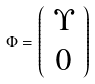<formula> <loc_0><loc_0><loc_500><loc_500>\Phi = \left ( \begin{array} { c } \Upsilon \\ 0 \end{array} \right )</formula> 